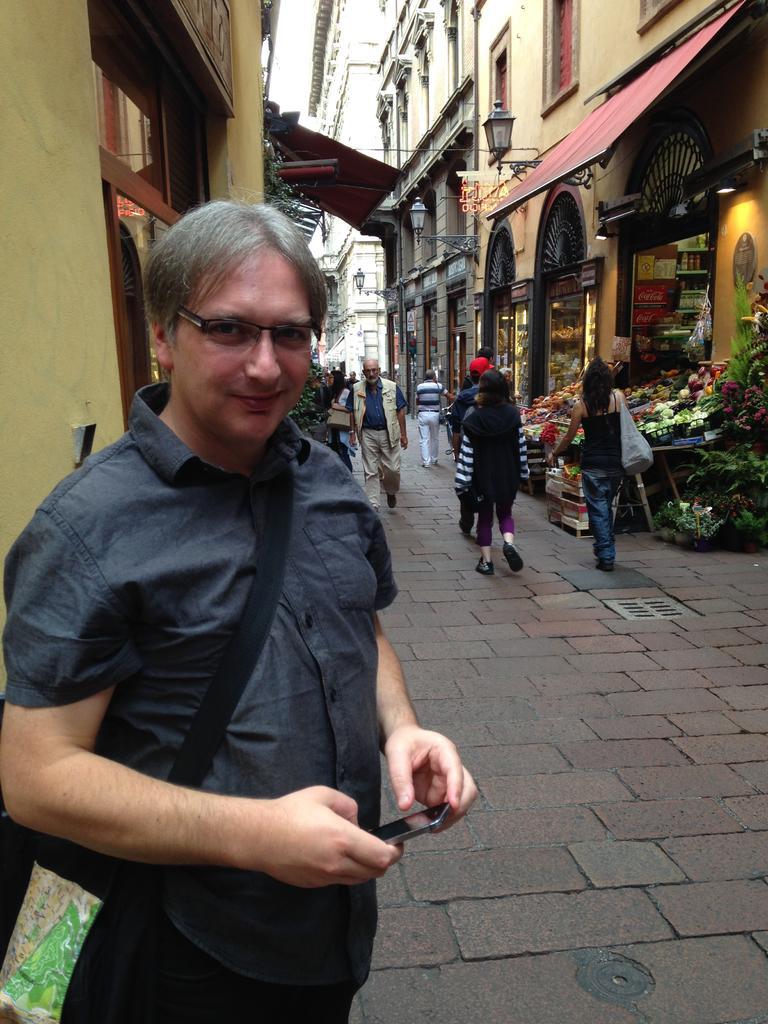In one or two sentences, can you explain what this image depicts? In this image we can see buildings, persons standing on the roadside, vegetable stall, street light and grills. 